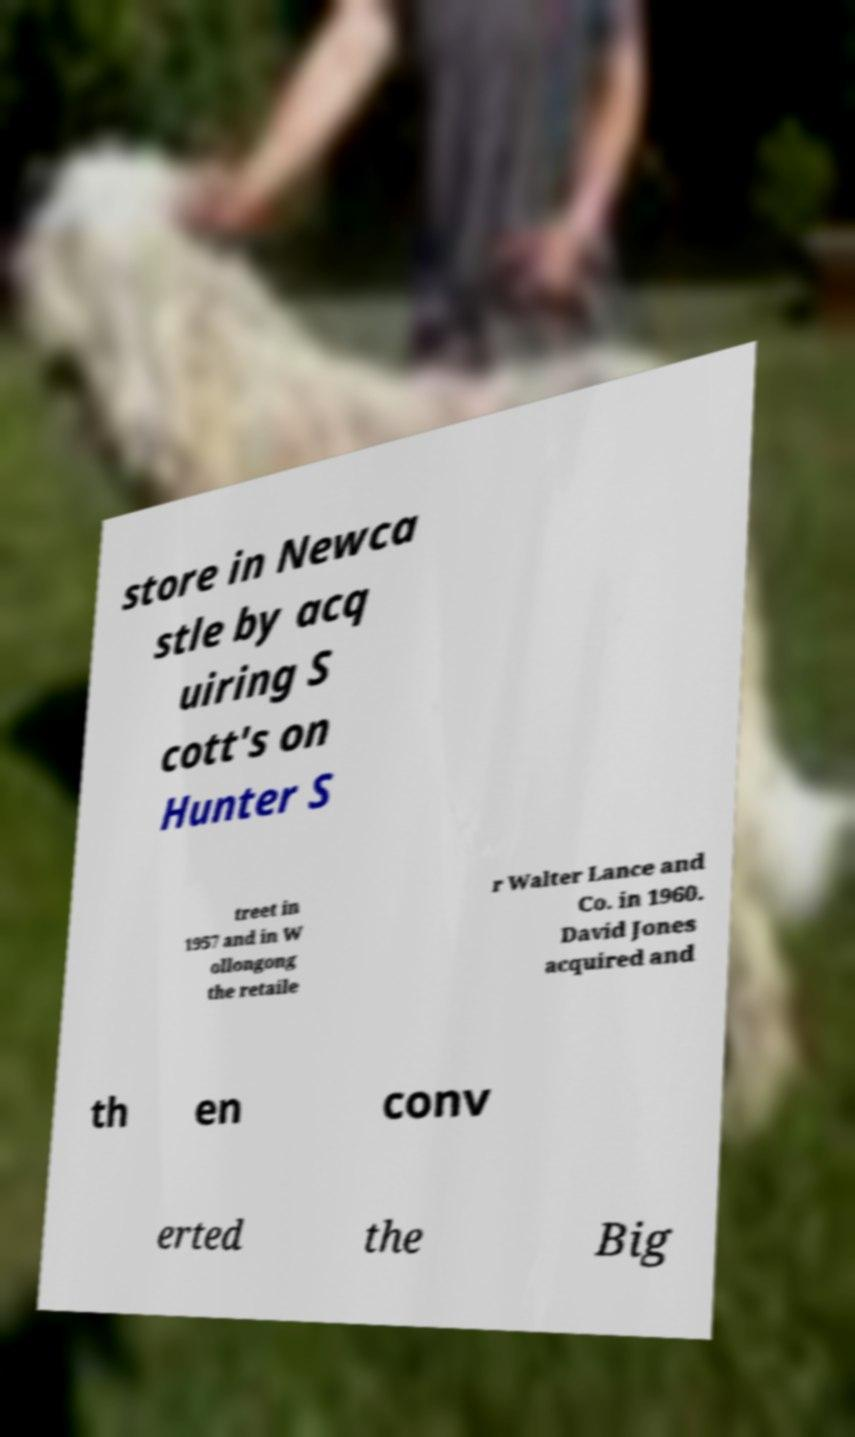Please read and relay the text visible in this image. What does it say? store in Newca stle by acq uiring S cott's on Hunter S treet in 1957 and in W ollongong the retaile r Walter Lance and Co. in 1960. David Jones acquired and th en conv erted the Big 